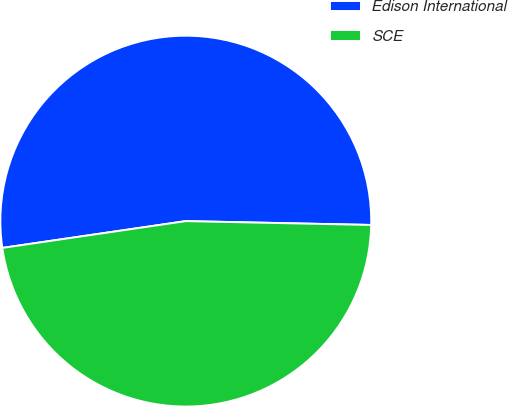<chart> <loc_0><loc_0><loc_500><loc_500><pie_chart><fcel>Edison International<fcel>SCE<nl><fcel>52.64%<fcel>47.36%<nl></chart> 